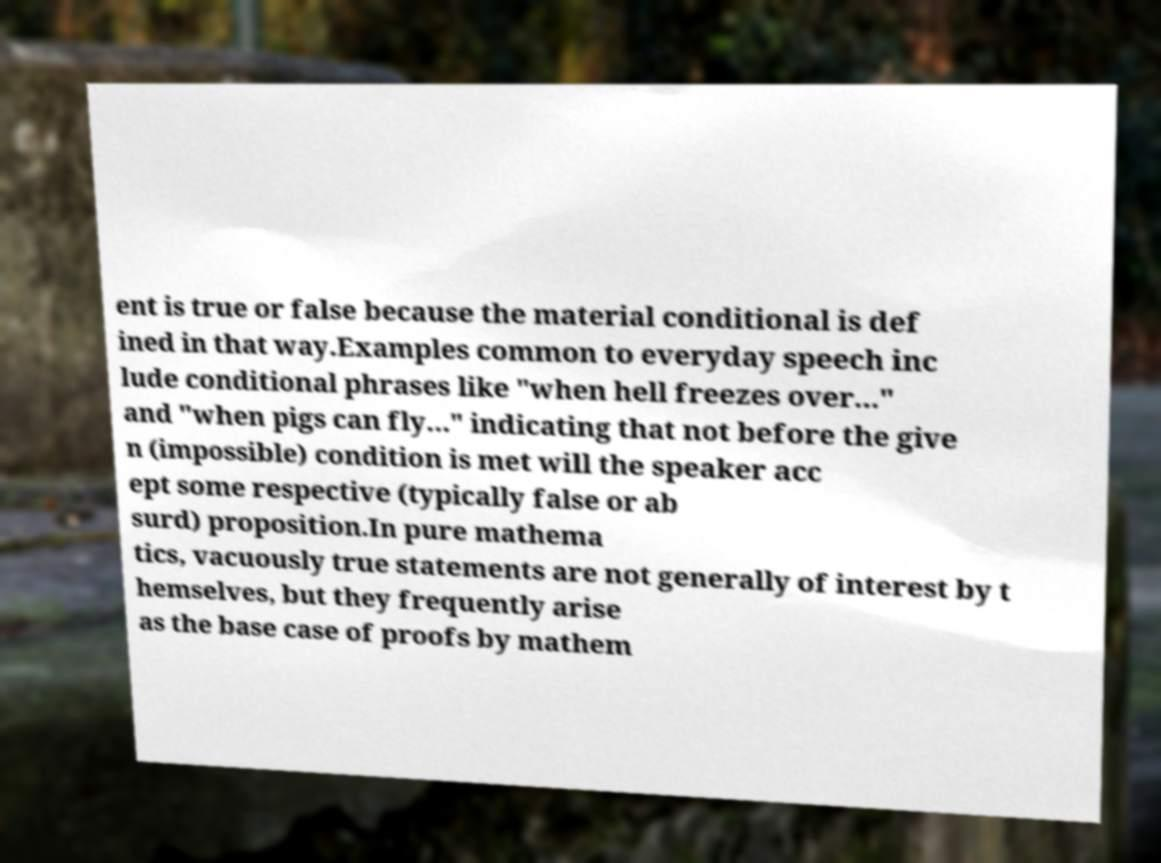There's text embedded in this image that I need extracted. Can you transcribe it verbatim? ent is true or false because the material conditional is def ined in that way.Examples common to everyday speech inc lude conditional phrases like "when hell freezes over..." and "when pigs can fly..." indicating that not before the give n (impossible) condition is met will the speaker acc ept some respective (typically false or ab surd) proposition.In pure mathema tics, vacuously true statements are not generally of interest by t hemselves, but they frequently arise as the base case of proofs by mathem 